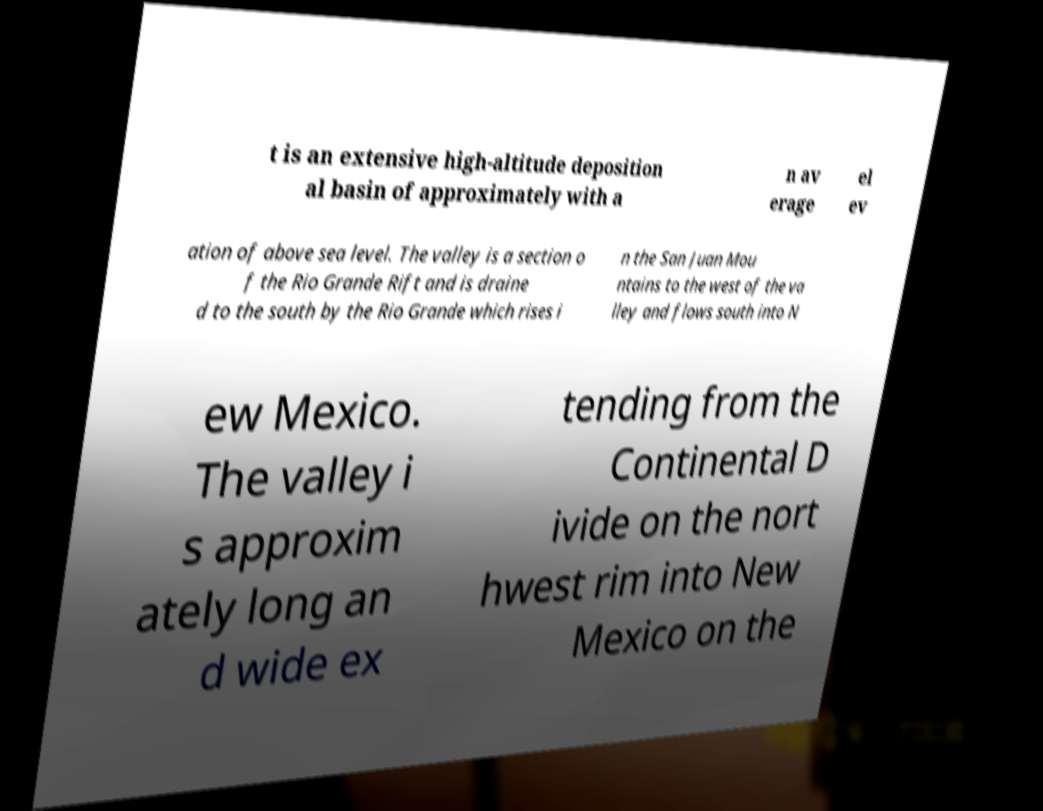Please identify and transcribe the text found in this image. t is an extensive high-altitude deposition al basin of approximately with a n av erage el ev ation of above sea level. The valley is a section o f the Rio Grande Rift and is draine d to the south by the Rio Grande which rises i n the San Juan Mou ntains to the west of the va lley and flows south into N ew Mexico. The valley i s approxim ately long an d wide ex tending from the Continental D ivide on the nort hwest rim into New Mexico on the 